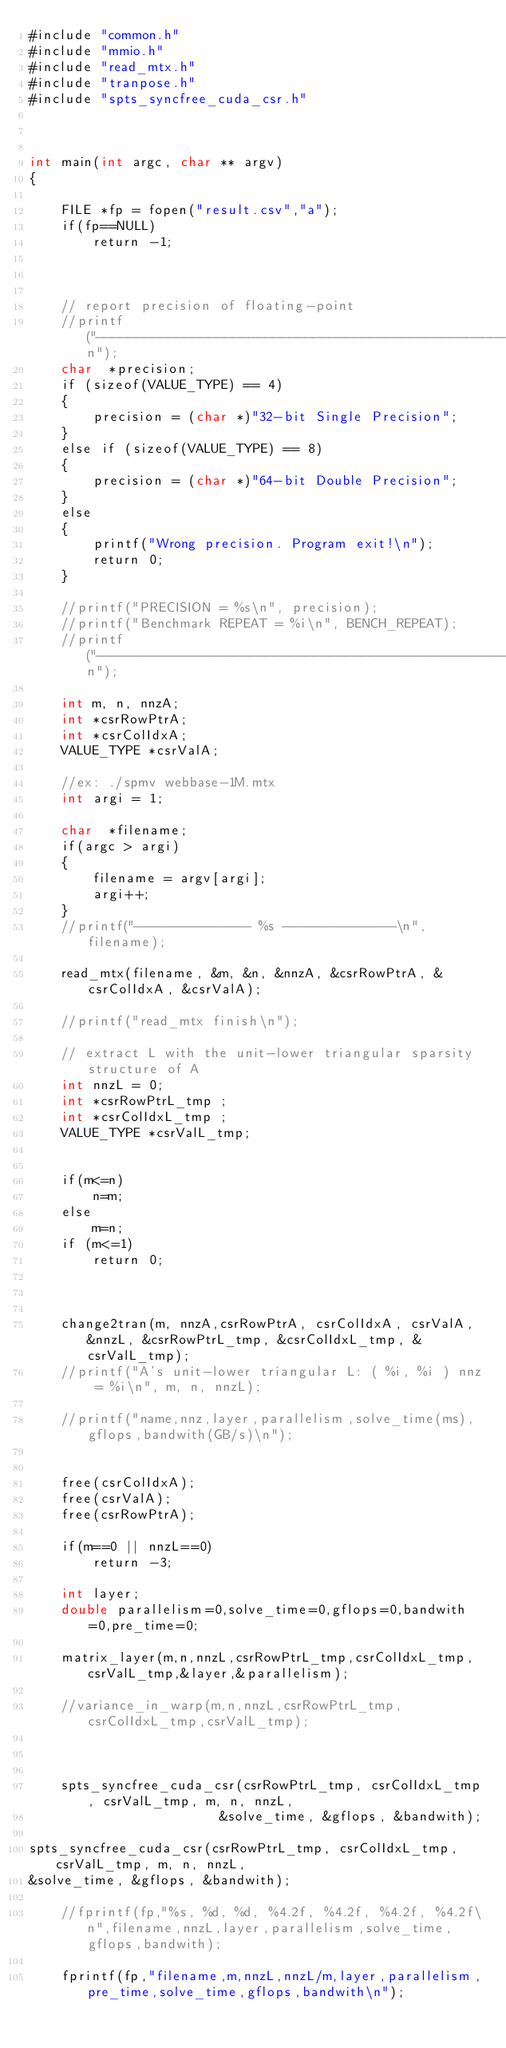<code> <loc_0><loc_0><loc_500><loc_500><_Cuda_>#include "common.h"
#include "mmio.h"
#include "read_mtx.h"
#include "tranpose.h"
#include "spts_syncfree_cuda_csr.h"



int main(int argc, char ** argv)
{

    FILE *fp = fopen("result.csv","a");
    if(fp==NULL)
        return -1;



    // report precision of floating-point
    //printf("---------------------------------------------------------------------------------------------\n");
    char  *precision;
    if (sizeof(VALUE_TYPE) == 4)
    {
        precision = (char *)"32-bit Single Precision";
    }
    else if (sizeof(VALUE_TYPE) == 8)
    {
        precision = (char *)"64-bit Double Precision";
    }
    else
    {
        printf("Wrong precision. Program exit!\n");
        return 0;
    }
    
    //printf("PRECISION = %s\n", precision);
    //printf("Benchmark REPEAT = %i\n", BENCH_REPEAT);
    //printf("---------------------------------------------------------------------------------------------\n");
    
    int m, n, nnzA;
    int *csrRowPtrA;
    int *csrColIdxA;
    VALUE_TYPE *csrValA;
    
    //ex: ./spmv webbase-1M.mtx
    int argi = 1;
    
    char  *filename;
    if(argc > argi)
    {
        filename = argv[argi];
        argi++;
    }
    //printf("-------------- %s --------------\n", filename);
    
    read_mtx(filename, &m, &n, &nnzA, &csrRowPtrA, &csrColIdxA, &csrValA);

    //printf("read_mtx finish\n");
    
    // extract L with the unit-lower triangular sparsity structure of A
    int nnzL = 0;
    int *csrRowPtrL_tmp ;
    int *csrColIdxL_tmp ;
    VALUE_TYPE *csrValL_tmp;


    if(m<=n)
        n=m;
    else
        m=n;
    if (m<=1)
        return 0;


    
    change2tran(m, nnzA,csrRowPtrA, csrColIdxA, csrValA, &nnzL, &csrRowPtrL_tmp, &csrColIdxL_tmp, &csrValL_tmp);
    //printf("A's unit-lower triangular L: ( %i, %i ) nnz = %i\n", m, n, nnzL);

    //printf("name,nnz,layer,parallelism,solve_time(ms),gflops,bandwith(GB/s)\n");

    
    free(csrColIdxA);
    free(csrValA);
    free(csrRowPtrA);

    if(m==0 || nnzL==0)
        return -3;

    int layer;
    double parallelism=0,solve_time=0,gflops=0,bandwith=0,pre_time=0;

    matrix_layer(m,n,nnzL,csrRowPtrL_tmp,csrColIdxL_tmp,csrValL_tmp,&layer,&parallelism);

    //variance_in_warp(m,n,nnzL,csrRowPtrL_tmp,csrColIdxL_tmp,csrValL_tmp);
    
    

    spts_syncfree_cuda_csr(csrRowPtrL_tmp, csrColIdxL_tmp, csrValL_tmp, m, n, nnzL,
                        &solve_time, &gflops, &bandwith);

spts_syncfree_cuda_csr(csrRowPtrL_tmp, csrColIdxL_tmp, csrValL_tmp, m, n, nnzL,
&solve_time, &gflops, &bandwith);

    //fprintf(fp,"%s, %d, %d, %4.2f, %4.2f, %4.2f, %4.2f\n",filename,nnzL,layer,parallelism,solve_time,gflops,bandwith);

    fprintf(fp,"filename,m,nnzL,nnzL/m,layer,parallelism,pre_time,solve_time,gflops,bandwith\n");</code> 